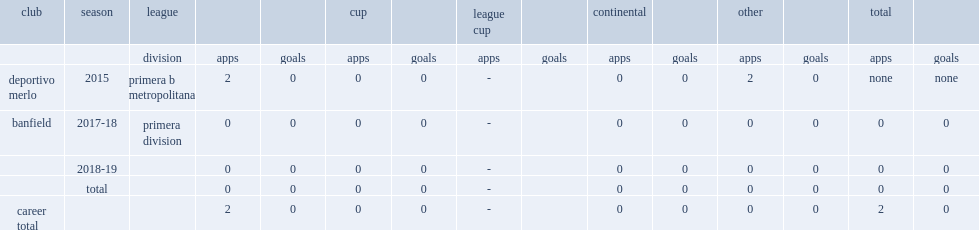Brizuela's first career club was deportivo merlo, which division was during the 2015? Primera b metropolitana. 